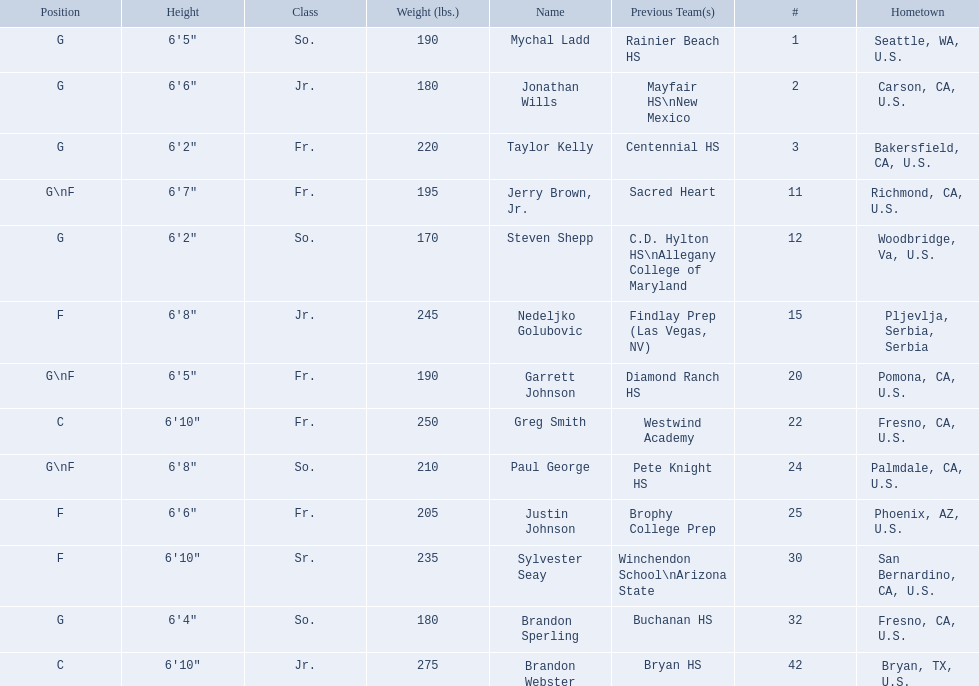What class was each team member in for the 2009-10 fresno state bulldogs? So., Jr., Fr., Fr., So., Jr., Fr., Fr., So., Fr., Sr., So., Jr. Which of these was outside of the us? Jr. Who was the player? Nedeljko Golubovic. 